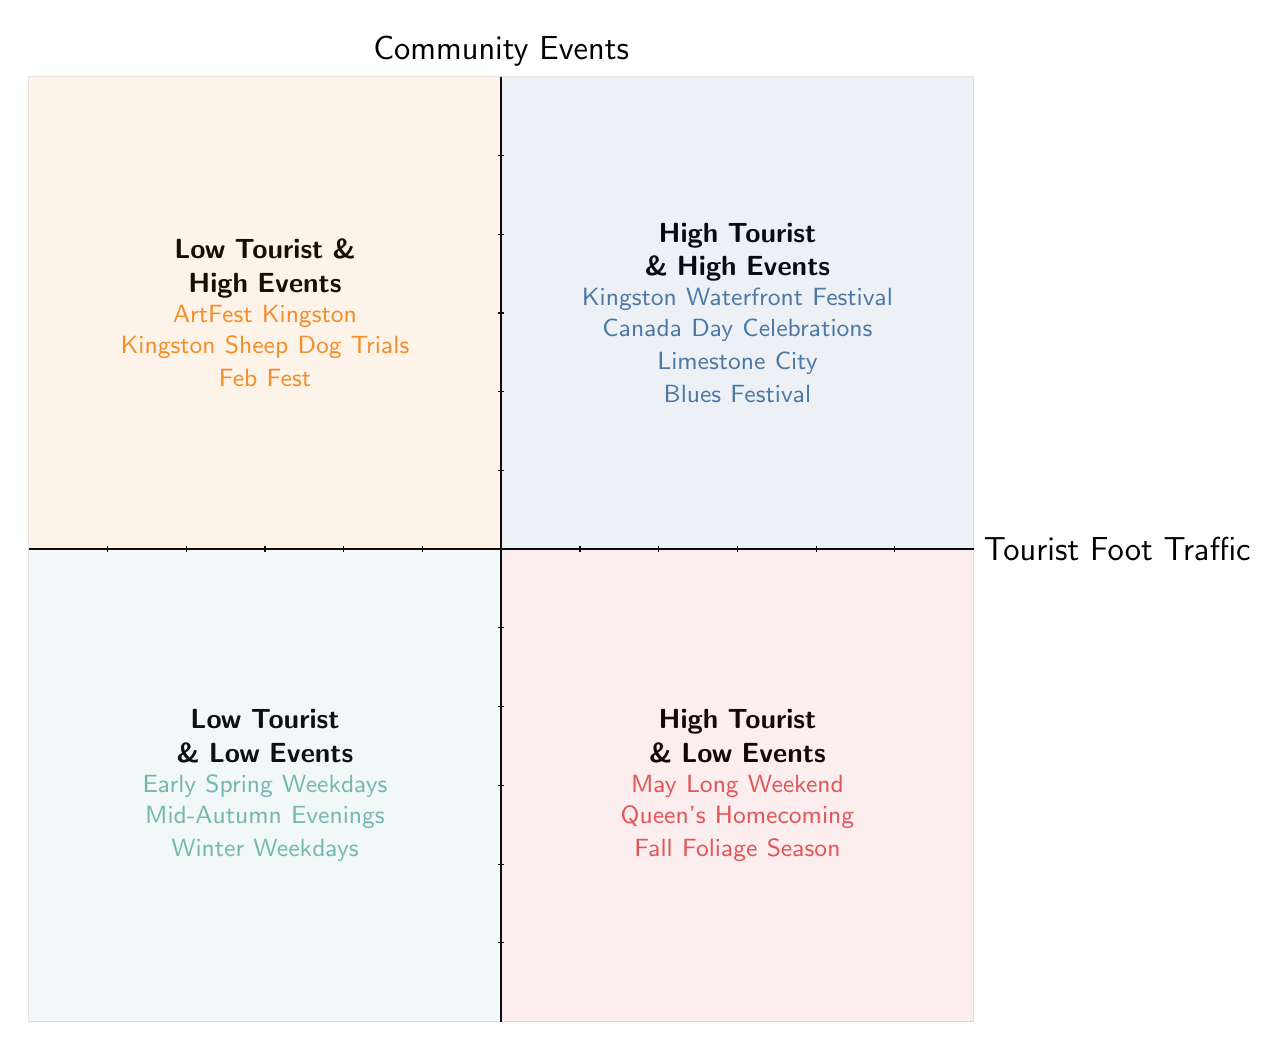What events are listed in Quadrant 1? Quadrant 1 includes events categorized as having high tourist foot traffic and high community events. The listed events are Kingston Waterfront Festival, Canada Day Celebrations, and Limestone City Blues Festival.
Answer: Kingston Waterfront Festival, Canada Day Celebrations, Limestone City Blues Festival Which quadrant has the fewest events? Quadrant 4 includes the least number of events, which are categorized as low tourist foot traffic and low community events. It lists three events: Early Spring Weekdays, Mid-Autumn Evenings, and Winter Weekdays. Since Quadrant 4 has only three events, it is the quadrant with the fewest events.
Answer: Quadrant 4 In which quadrant can the Kingston Sheep Dog Trials be found? Kingston Sheep Dog Trials is listed in Quadrant 2, which represents low tourist foot traffic and high community events.
Answer: Quadrant 2 What is the main characteristic of events in Quadrant 3? Quadrant 3 events have high tourist foot traffic but low community events. The events listed serve as examples of this characteristic.
Answer: High tourist foot traffic & low community events How many events are listed in total across all quadrants? To find the total number of events, add the events from all quadrants: Quadrant 1 has 3 events, Quadrant 2 has 3 events, Quadrant 3 has 3 events, and Quadrant 4 has 3 events, totaling 12 events.
Answer: 12 events What is the overall pattern regarding community events and tourist foot traffic in Kingston? The quadrants illustrate a relationship between community events and tourist foot traffic: Quadrant 1 has both high, while Quadrant 2 has high community events but low foot traffic. Quadrant 3 shows the opposite with high foot traffic and low events, while Quadrant 4 indicates low for both. This suggests a seasonal variation in attendance at community events.
Answer: Seasonal variation in attendance 